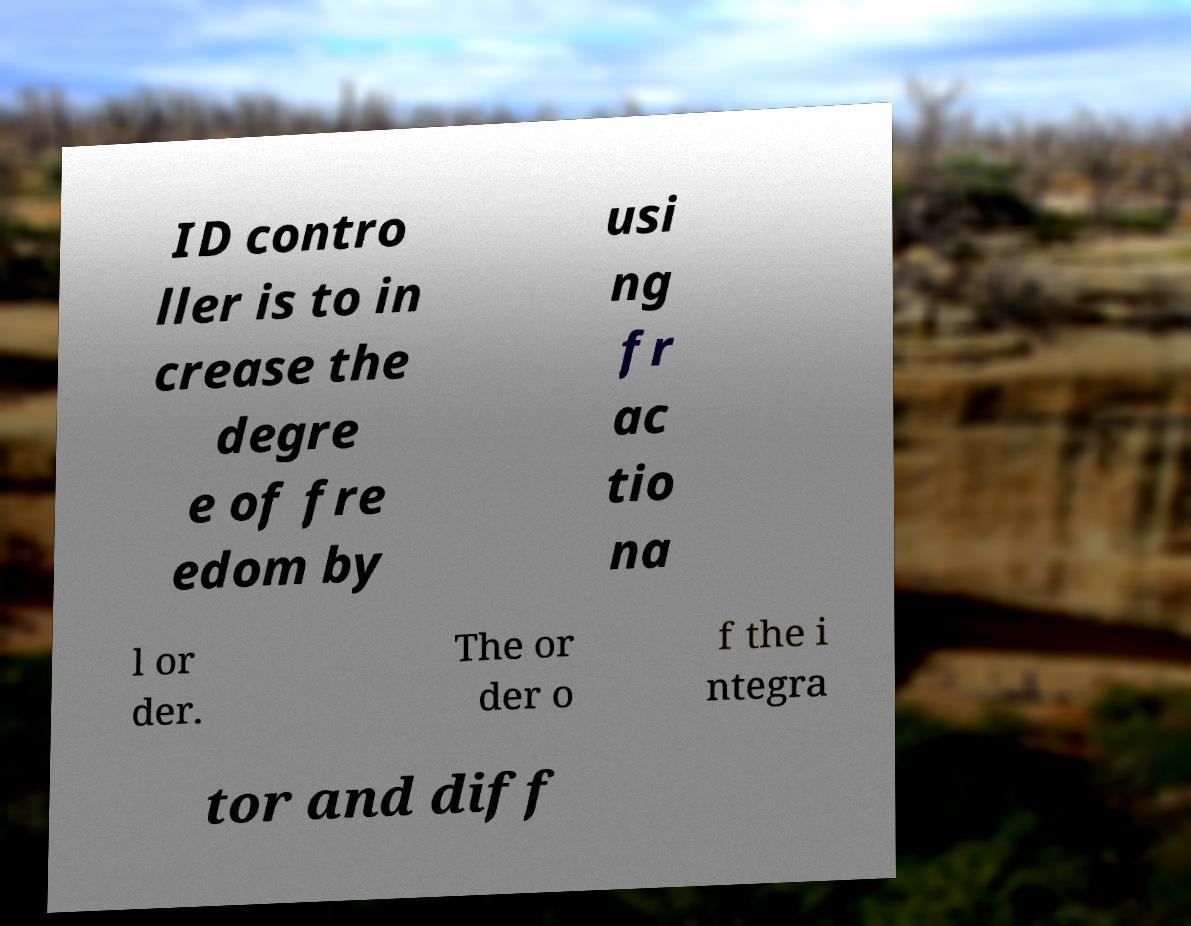Could you extract and type out the text from this image? ID contro ller is to in crease the degre e of fre edom by usi ng fr ac tio na l or der. The or der o f the i ntegra tor and diff 